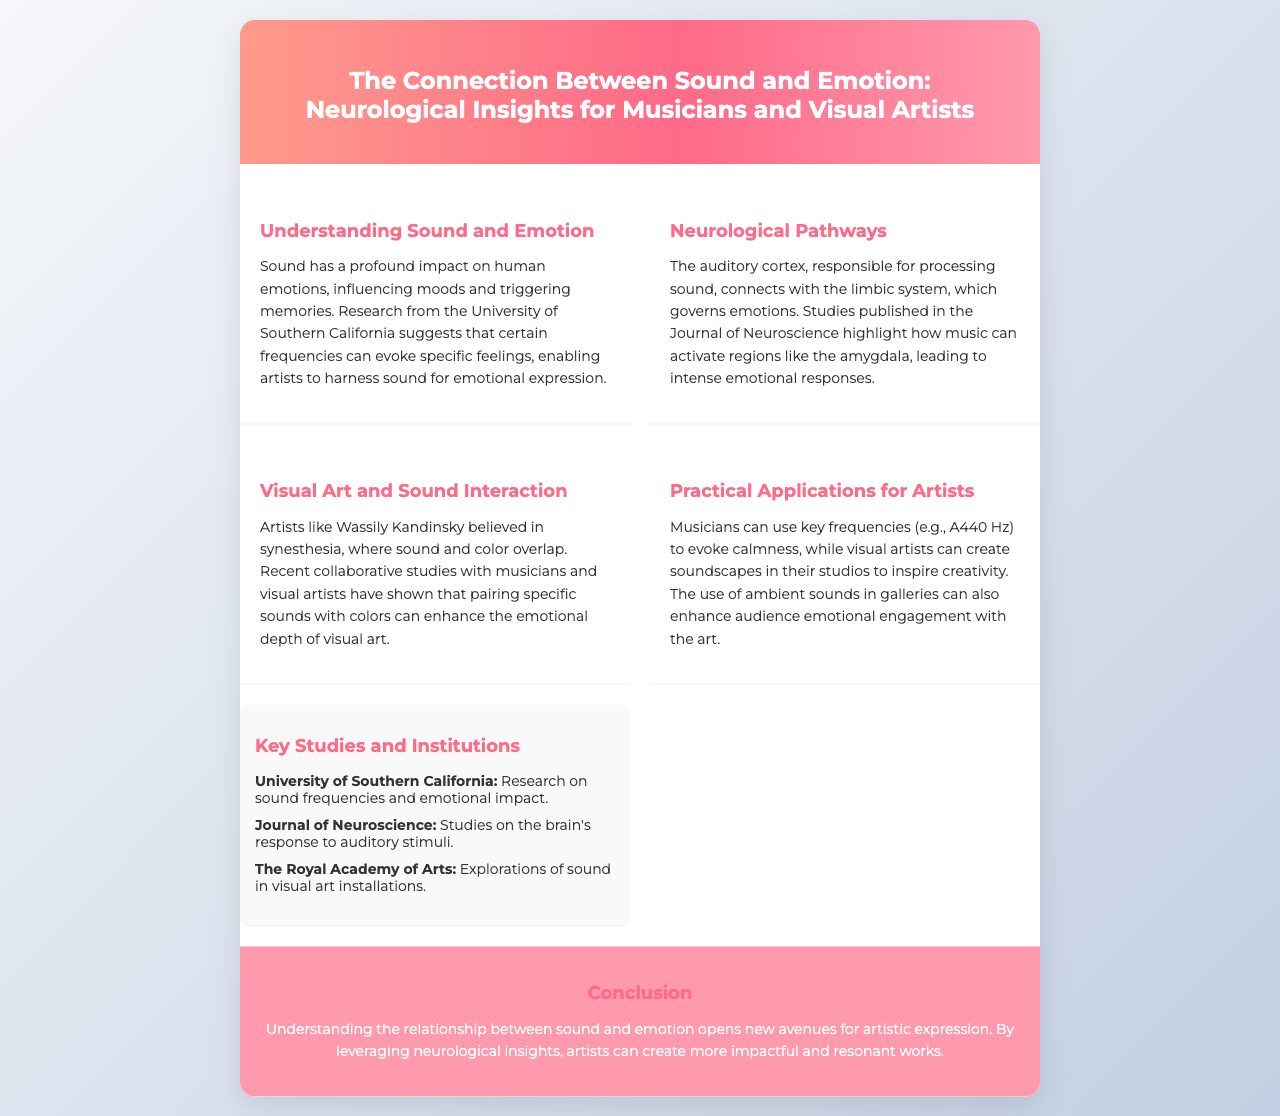what is the title of the brochure? The title is explicitly stated in the header of the brochure.
Answer: The Connection Between Sound and Emotion: Neurological Insights for Musicians and Visual Artists which university conducted research on sound frequencies? The brochure mentions this university in the context of its research on sound.
Answer: University of Southern California what does the auditory cortex connect with? This connection is described in the section about neurological pathways.
Answer: Limbic system who believed in synesthesia? The brochure references this artist when discussing sound and color interaction.
Answer: Wassily Kandinsky what frequency is mentioned as evoking calmness for musicians? The document states a specific frequency associated with calmness.
Answer: A440 Hz which journal published studies on the brain's response to auditory stimuli? The name of the journal is found in the section discussing key studies.
Answer: Journal of Neuroscience what emotional response does activating the amygdala lead to? The brochure implies a general emotional outcome associated with activating this brain region.
Answer: Intense emotional responses how can visual artists enhance audience engagement? The document suggests a practical application for visual artists regarding audience connection.
Answer: Ambient sounds in galleries what are artists encouraged to harness for emotional expression? This concept is summarized in the understanding sound and emotion section.
Answer: Sound 